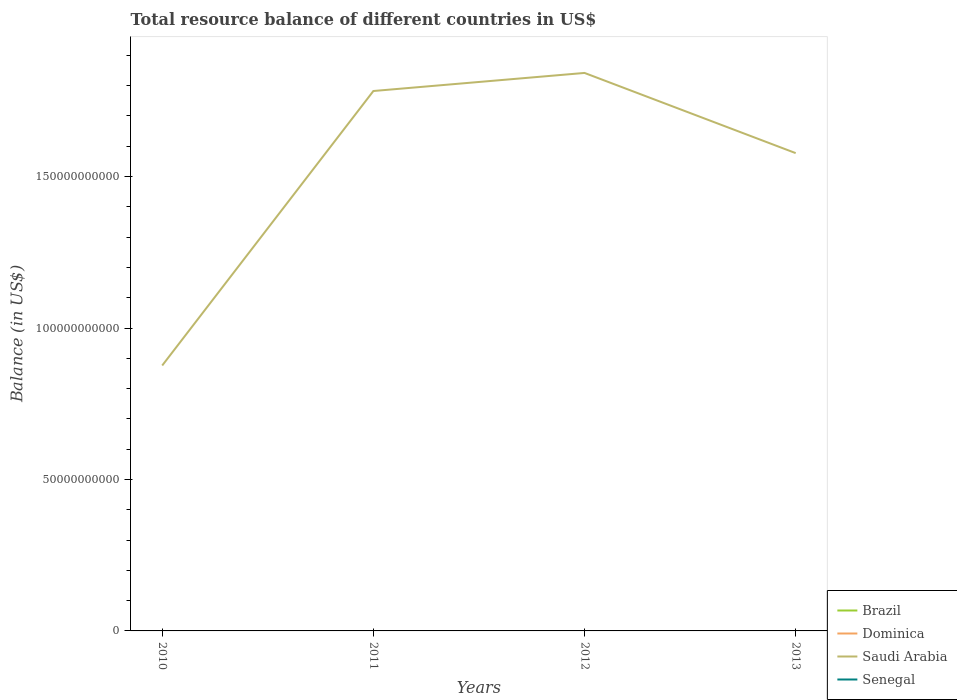How many different coloured lines are there?
Make the answer very short. 1. Does the line corresponding to Dominica intersect with the line corresponding to Saudi Arabia?
Ensure brevity in your answer.  No. Across all years, what is the maximum total resource balance in Dominica?
Offer a terse response. 0. What is the difference between the highest and the second highest total resource balance in Saudi Arabia?
Your response must be concise. 9.66e+1. What is the difference between the highest and the lowest total resource balance in Senegal?
Provide a short and direct response. 0. How many lines are there?
Offer a terse response. 1. Does the graph contain any zero values?
Provide a short and direct response. Yes. Does the graph contain grids?
Offer a terse response. No. Where does the legend appear in the graph?
Your answer should be very brief. Bottom right. How many legend labels are there?
Ensure brevity in your answer.  4. How are the legend labels stacked?
Offer a very short reply. Vertical. What is the title of the graph?
Make the answer very short. Total resource balance of different countries in US$. Does "Qatar" appear as one of the legend labels in the graph?
Offer a terse response. No. What is the label or title of the X-axis?
Offer a very short reply. Years. What is the label or title of the Y-axis?
Ensure brevity in your answer.  Balance (in US$). What is the Balance (in US$) of Brazil in 2010?
Offer a very short reply. 0. What is the Balance (in US$) of Saudi Arabia in 2010?
Give a very brief answer. 8.76e+1. What is the Balance (in US$) in Senegal in 2010?
Offer a very short reply. 0. What is the Balance (in US$) in Dominica in 2011?
Your answer should be very brief. 0. What is the Balance (in US$) in Saudi Arabia in 2011?
Offer a terse response. 1.78e+11. What is the Balance (in US$) of Senegal in 2011?
Provide a succinct answer. 0. What is the Balance (in US$) in Dominica in 2012?
Offer a terse response. 0. What is the Balance (in US$) of Saudi Arabia in 2012?
Offer a terse response. 1.84e+11. What is the Balance (in US$) of Brazil in 2013?
Your answer should be compact. 0. What is the Balance (in US$) in Saudi Arabia in 2013?
Offer a very short reply. 1.58e+11. Across all years, what is the maximum Balance (in US$) of Saudi Arabia?
Offer a terse response. 1.84e+11. Across all years, what is the minimum Balance (in US$) in Saudi Arabia?
Your answer should be very brief. 8.76e+1. What is the total Balance (in US$) in Brazil in the graph?
Provide a succinct answer. 0. What is the total Balance (in US$) of Dominica in the graph?
Make the answer very short. 0. What is the total Balance (in US$) of Saudi Arabia in the graph?
Your response must be concise. 6.08e+11. What is the difference between the Balance (in US$) in Saudi Arabia in 2010 and that in 2011?
Offer a very short reply. -9.06e+1. What is the difference between the Balance (in US$) of Saudi Arabia in 2010 and that in 2012?
Keep it short and to the point. -9.66e+1. What is the difference between the Balance (in US$) in Saudi Arabia in 2010 and that in 2013?
Give a very brief answer. -7.01e+1. What is the difference between the Balance (in US$) in Saudi Arabia in 2011 and that in 2012?
Your answer should be very brief. -5.97e+09. What is the difference between the Balance (in US$) in Saudi Arabia in 2011 and that in 2013?
Offer a terse response. 2.05e+1. What is the difference between the Balance (in US$) of Saudi Arabia in 2012 and that in 2013?
Provide a short and direct response. 2.65e+1. What is the average Balance (in US$) in Brazil per year?
Provide a succinct answer. 0. What is the average Balance (in US$) of Saudi Arabia per year?
Offer a terse response. 1.52e+11. What is the ratio of the Balance (in US$) of Saudi Arabia in 2010 to that in 2011?
Your answer should be very brief. 0.49. What is the ratio of the Balance (in US$) in Saudi Arabia in 2010 to that in 2012?
Provide a short and direct response. 0.48. What is the ratio of the Balance (in US$) in Saudi Arabia in 2010 to that in 2013?
Your answer should be very brief. 0.56. What is the ratio of the Balance (in US$) in Saudi Arabia in 2011 to that in 2012?
Provide a short and direct response. 0.97. What is the ratio of the Balance (in US$) of Saudi Arabia in 2011 to that in 2013?
Offer a very short reply. 1.13. What is the ratio of the Balance (in US$) of Saudi Arabia in 2012 to that in 2013?
Keep it short and to the point. 1.17. What is the difference between the highest and the second highest Balance (in US$) in Saudi Arabia?
Ensure brevity in your answer.  5.97e+09. What is the difference between the highest and the lowest Balance (in US$) of Saudi Arabia?
Make the answer very short. 9.66e+1. 